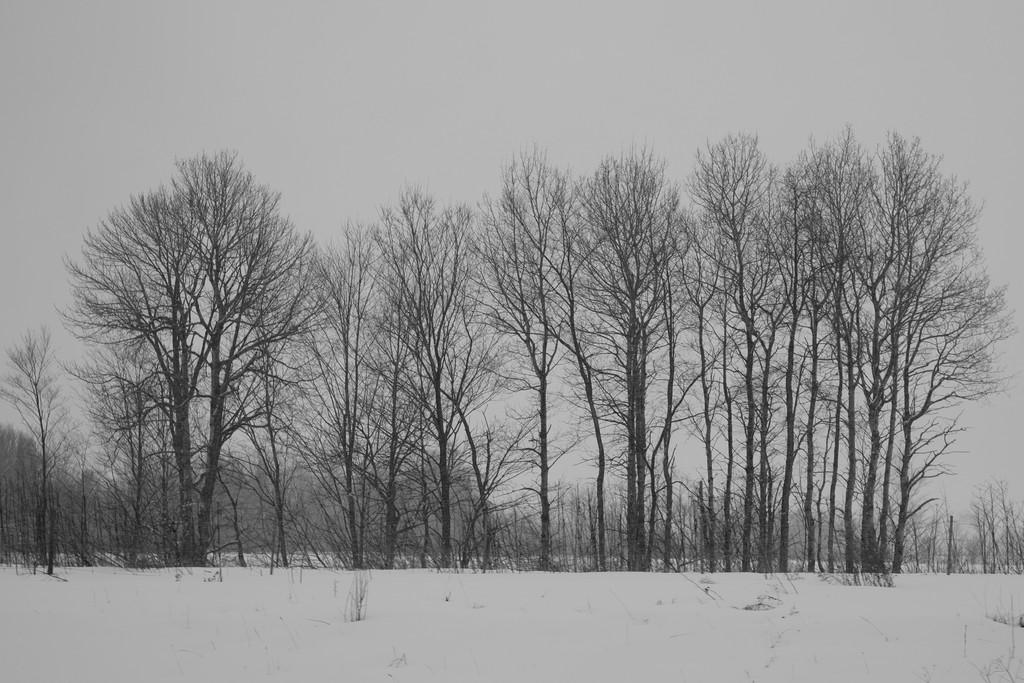What is the overall color of the image? The image has a snow white color. What type of natural elements can be seen in the image? There are many trees in the image. What part of the natural environment is visible in the image? The sky is visible in the image. What type of sack is being used to carry the glue in the image? There is no sack or glue present in the image. What kind of vessel is visible in the image? There is no vessel present in the image. 